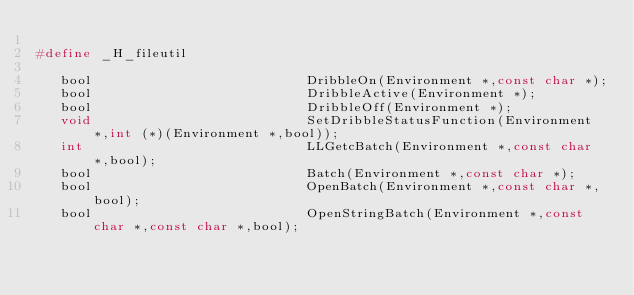<code> <loc_0><loc_0><loc_500><loc_500><_C_>
#define _H_fileutil

   bool                           DribbleOn(Environment *,const char *);
   bool                           DribbleActive(Environment *);
   bool                           DribbleOff(Environment *);
   void                           SetDribbleStatusFunction(Environment *,int (*)(Environment *,bool));
   int                            LLGetcBatch(Environment *,const char *,bool);
   bool                           Batch(Environment *,const char *);
   bool                           OpenBatch(Environment *,const char *,bool);
   bool                           OpenStringBatch(Environment *,const char *,const char *,bool);</code> 